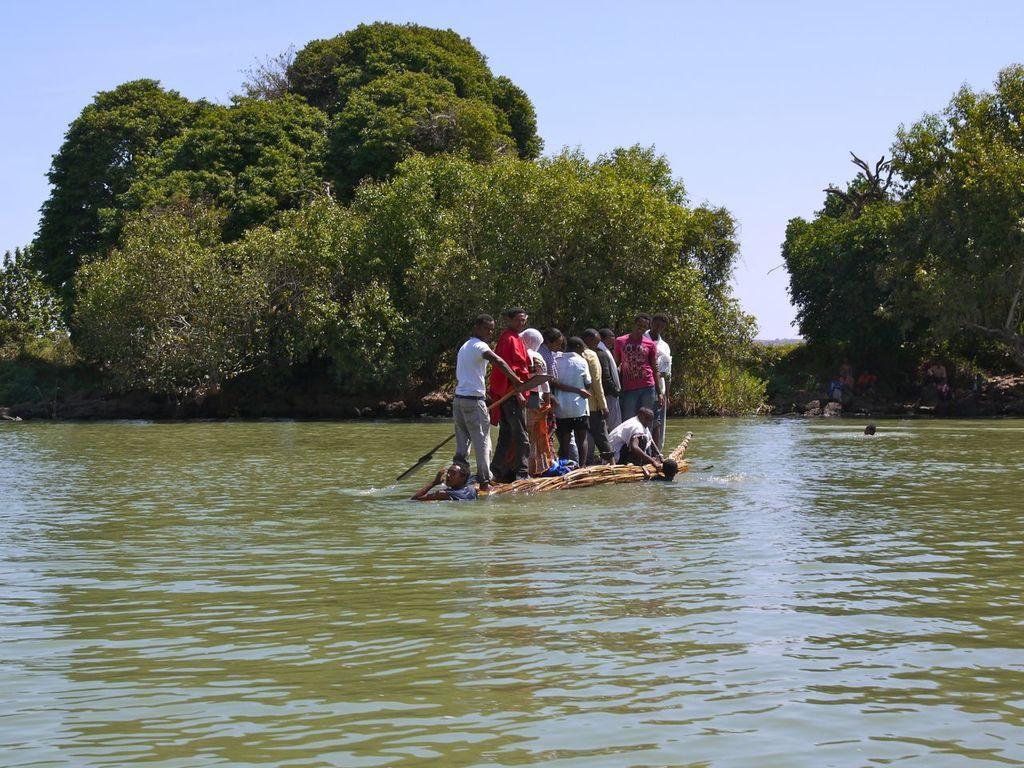Please provide a concise description of this image. This image is taken in outdoors. In the bottom of the image there is a pond with water in it. In the middle of the image there are few people standing on the boat with a pads in their hands. In the background there many trees and plants. At the top of the image there is a sky. 